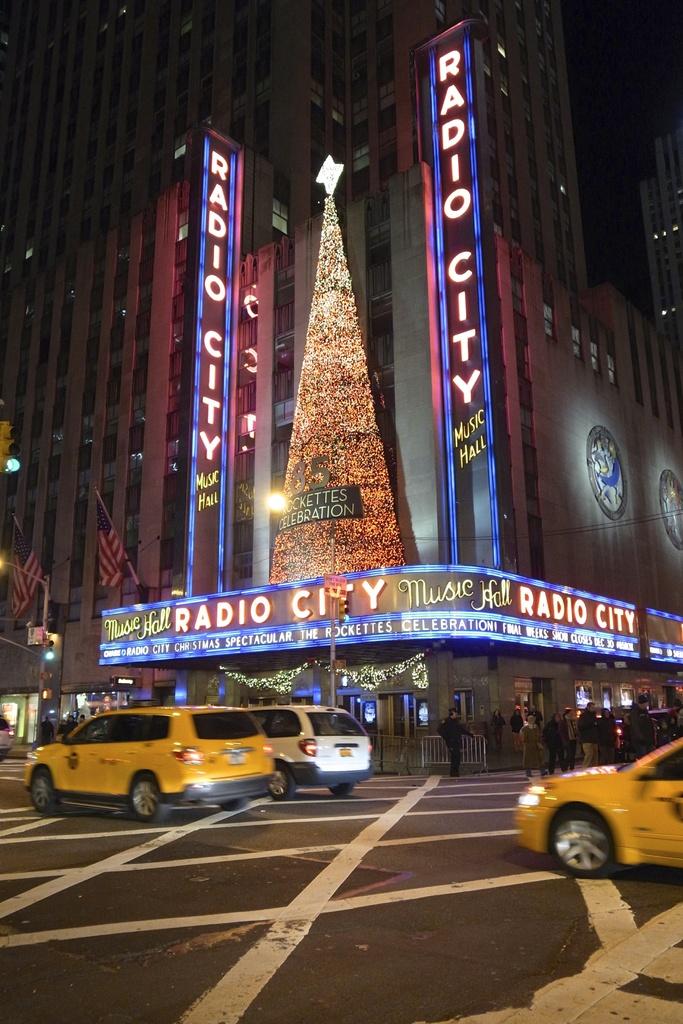What name is repeated four times on the sign?
Give a very brief answer. Radio city. 